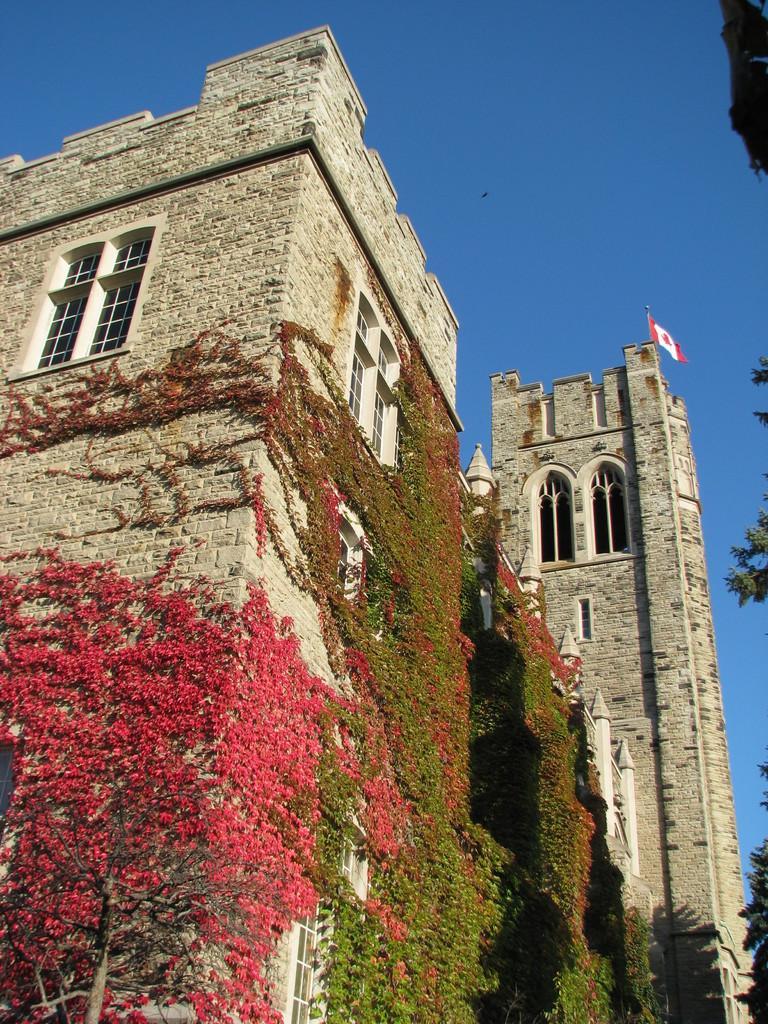How would you summarize this image in a sentence or two? This picture is clicked outside. In the center we can see the buildings and the windows of the buildings and we can see the leaves. In the background we can see the sky, flag, trees and some other objects. 